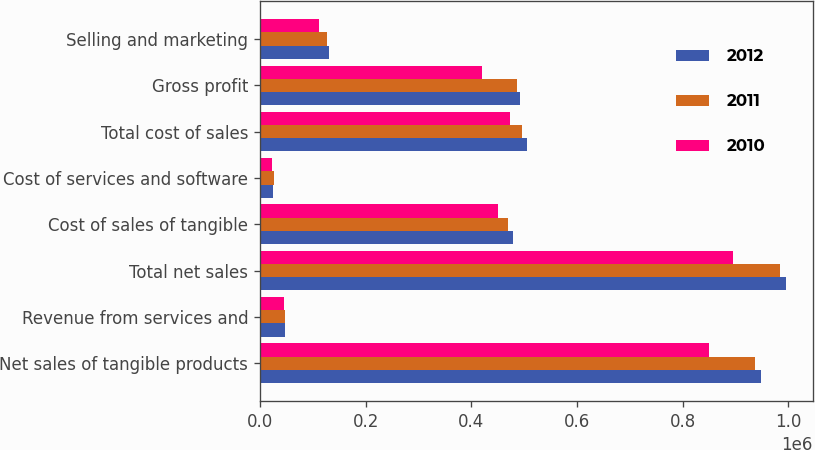<chart> <loc_0><loc_0><loc_500><loc_500><stacked_bar_chart><ecel><fcel>Net sales of tangible products<fcel>Revenue from services and<fcel>Total net sales<fcel>Cost of sales of tangible<fcel>Cost of services and software<fcel>Total cost of sales<fcel>Gross profit<fcel>Selling and marketing<nl><fcel>2012<fcel>948227<fcel>47941<fcel>996168<fcel>479633<fcel>24891<fcel>504524<fcel>491644<fcel>129906<nl><fcel>2011<fcel>936282<fcel>47206<fcel>983488<fcel>469834<fcel>26885<fcel>496719<fcel>486769<fcel>127797<nl><fcel>2010<fcel>849530<fcel>44829<fcel>894359<fcel>450630<fcel>22954<fcel>473584<fcel>420775<fcel>112365<nl></chart> 